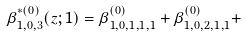<formula> <loc_0><loc_0><loc_500><loc_500>\beta ^ { \ast ( 0 ) } _ { 1 , 0 , 3 } ( z ; 1 ) = \beta _ { 1 , 0 , 1 , 1 , 1 } ^ { ( 0 ) } + \beta _ { 1 , 0 , 2 , 1 , 1 } ^ { ( 0 ) } +</formula> 